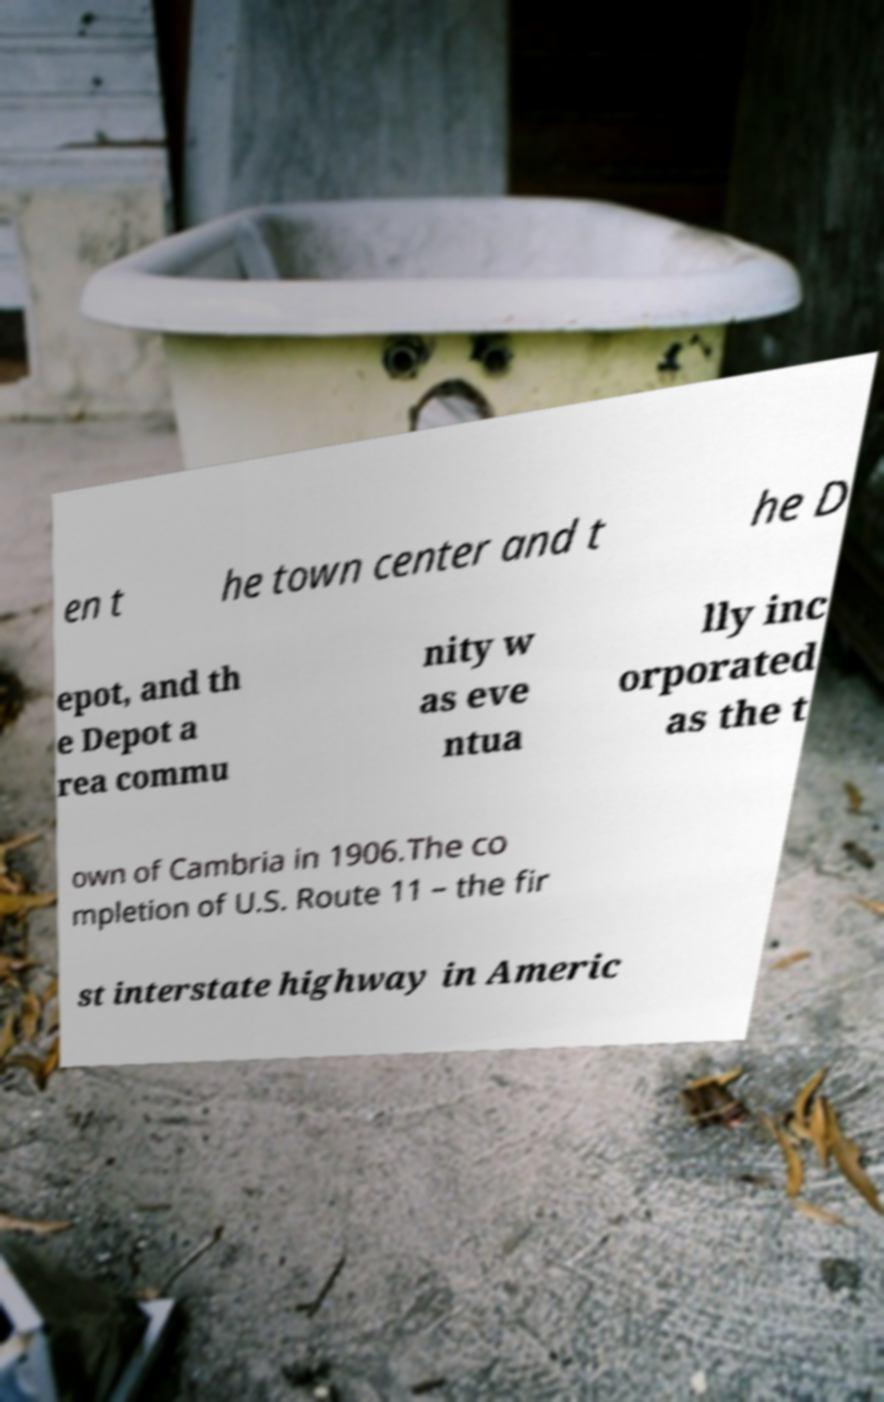What messages or text are displayed in this image? I need them in a readable, typed format. en t he town center and t he D epot, and th e Depot a rea commu nity w as eve ntua lly inc orporated as the t own of Cambria in 1906.The co mpletion of U.S. Route 11 – the fir st interstate highway in Americ 